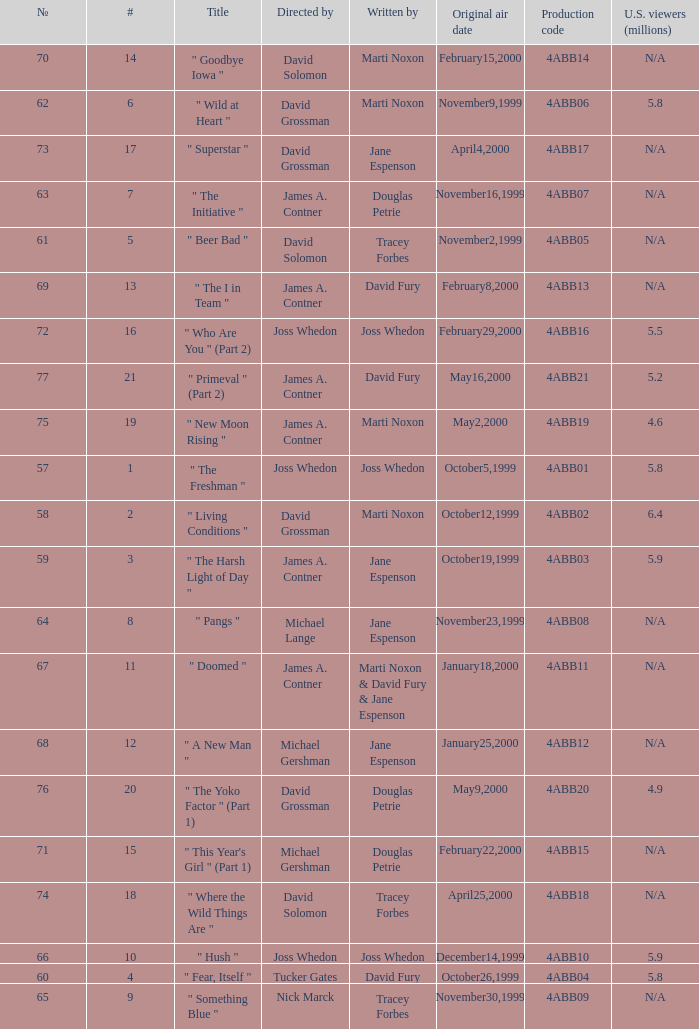Can you give me this table as a dict? {'header': ['№', '#', 'Title', 'Directed by', 'Written by', 'Original air date', 'Production code', 'U.S. viewers (millions)'], 'rows': [['70', '14', '" Goodbye Iowa "', 'David Solomon', 'Marti Noxon', 'February15,2000', '4ABB14', 'N/A'], ['62', '6', '" Wild at Heart "', 'David Grossman', 'Marti Noxon', 'November9,1999', '4ABB06', '5.8'], ['73', '17', '" Superstar "', 'David Grossman', 'Jane Espenson', 'April4,2000', '4ABB17', 'N/A'], ['63', '7', '" The Initiative "', 'James A. Contner', 'Douglas Petrie', 'November16,1999', '4ABB07', 'N/A'], ['61', '5', '" Beer Bad "', 'David Solomon', 'Tracey Forbes', 'November2,1999', '4ABB05', 'N/A'], ['69', '13', '" The I in Team "', 'James A. Contner', 'David Fury', 'February8,2000', '4ABB13', 'N/A'], ['72', '16', '" Who Are You " (Part 2)', 'Joss Whedon', 'Joss Whedon', 'February29,2000', '4ABB16', '5.5'], ['77', '21', '" Primeval " (Part 2)', 'James A. Contner', 'David Fury', 'May16,2000', '4ABB21', '5.2'], ['75', '19', '" New Moon Rising "', 'James A. Contner', 'Marti Noxon', 'May2,2000', '4ABB19', '4.6'], ['57', '1', '" The Freshman "', 'Joss Whedon', 'Joss Whedon', 'October5,1999', '4ABB01', '5.8'], ['58', '2', '" Living Conditions "', 'David Grossman', 'Marti Noxon', 'October12,1999', '4ABB02', '6.4'], ['59', '3', '" The Harsh Light of Day "', 'James A. Contner', 'Jane Espenson', 'October19,1999', '4ABB03', '5.9'], ['64', '8', '" Pangs "', 'Michael Lange', 'Jane Espenson', 'November23,1999', '4ABB08', 'N/A'], ['67', '11', '" Doomed "', 'James A. Contner', 'Marti Noxon & David Fury & Jane Espenson', 'January18,2000', '4ABB11', 'N/A'], ['68', '12', '" A New Man "', 'Michael Gershman', 'Jane Espenson', 'January25,2000', '4ABB12', 'N/A'], ['76', '20', '" The Yoko Factor " (Part 1)', 'David Grossman', 'Douglas Petrie', 'May9,2000', '4ABB20', '4.9'], ['71', '15', '" This Year\'s Girl " (Part 1)', 'Michael Gershman', 'Douglas Petrie', 'February22,2000', '4ABB15', 'N/A'], ['74', '18', '" Where the Wild Things Are "', 'David Solomon', 'Tracey Forbes', 'April25,2000', '4ABB18', 'N/A'], ['66', '10', '" Hush "', 'Joss Whedon', 'Joss Whedon', 'December14,1999', '4ABB10', '5.9'], ['60', '4', '" Fear, Itself "', 'Tucker Gates', 'David Fury', 'October26,1999', '4ABB04', '5.8'], ['65', '9', '" Something Blue "', 'Nick Marck', 'Tracey Forbes', 'November30,1999', '4ABB09', 'N/A']]} What is the title of episode No. 65? " Something Blue ". 